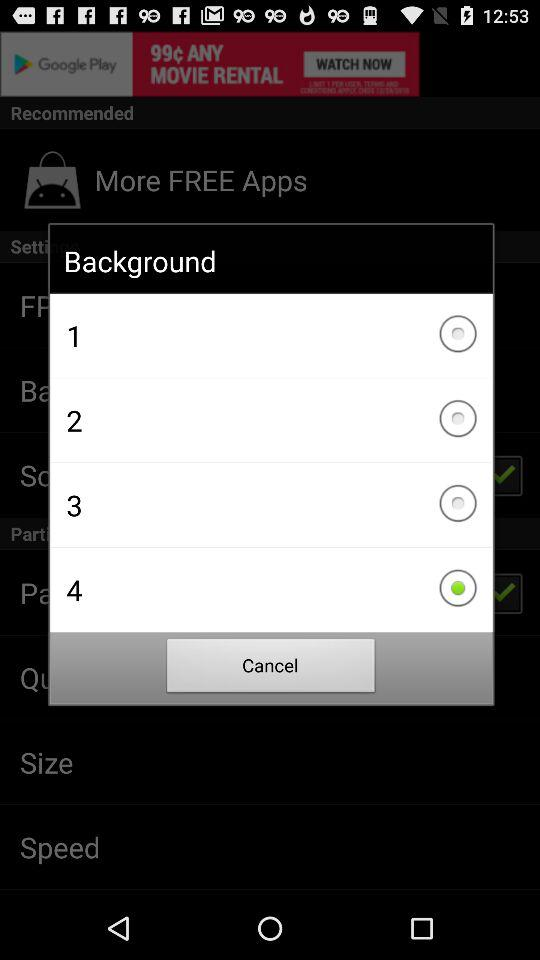What is the number selected in "Background"? The selected number in "Background" is 4. 